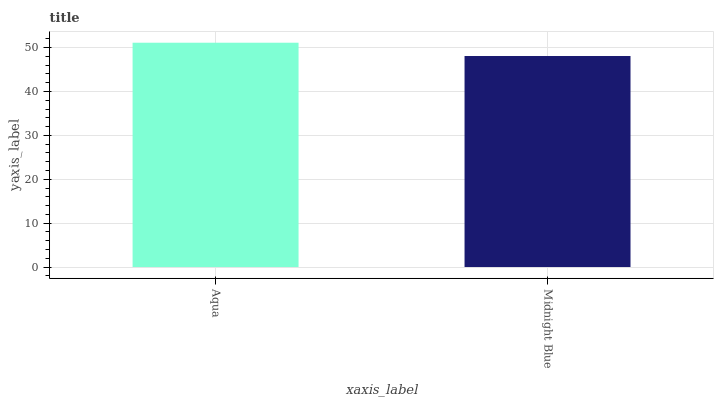Is Midnight Blue the minimum?
Answer yes or no. Yes. Is Aqua the maximum?
Answer yes or no. Yes. Is Midnight Blue the maximum?
Answer yes or no. No. Is Aqua greater than Midnight Blue?
Answer yes or no. Yes. Is Midnight Blue less than Aqua?
Answer yes or no. Yes. Is Midnight Blue greater than Aqua?
Answer yes or no. No. Is Aqua less than Midnight Blue?
Answer yes or no. No. Is Aqua the high median?
Answer yes or no. Yes. Is Midnight Blue the low median?
Answer yes or no. Yes. Is Midnight Blue the high median?
Answer yes or no. No. Is Aqua the low median?
Answer yes or no. No. 